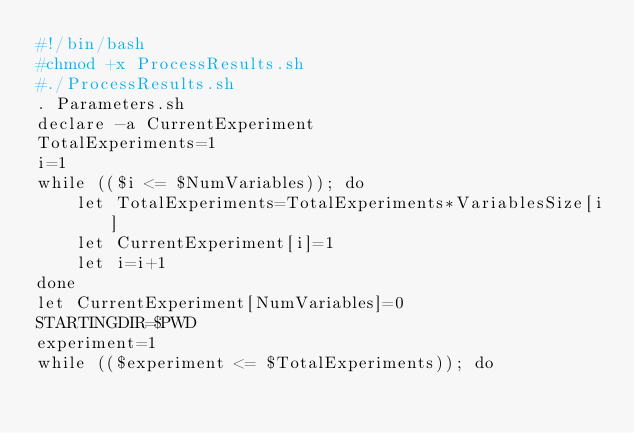<code> <loc_0><loc_0><loc_500><loc_500><_Bash_>#!/bin/bash
#chmod +x ProcessResults.sh
#./ProcessResults.sh
. Parameters.sh
declare -a CurrentExperiment
TotalExperiments=1
i=1
while (($i <= $NumVariables)); do
	let TotalExperiments=TotalExperiments*VariablesSize[i]
	let CurrentExperiment[i]=1
	let i=i+1
done
let CurrentExperiment[NumVariables]=0
STARTINGDIR=$PWD
experiment=1
while (($experiment <= $TotalExperiments)); do</code> 